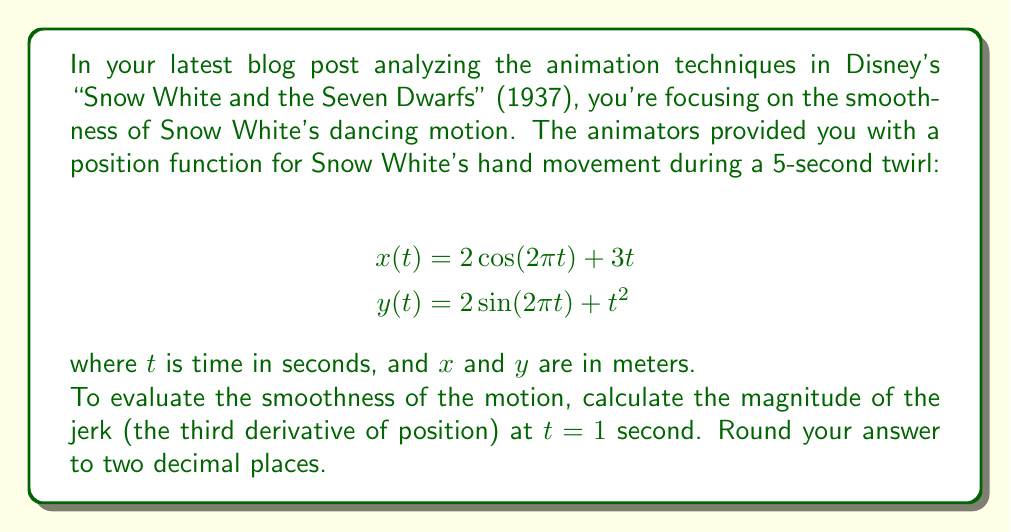What is the answer to this math problem? To evaluate the smoothness of the motion, we need to calculate the jerk, which is the third derivative of position. Let's break this down step-by-step:

1. First, we need to find the velocity components (first derivatives):
   $$\frac{dx}{dt} = -4\pi\sin(2\pi t) + 3$$
   $$\frac{dy}{dt} = 4\pi\cos(2\pi t) + 2t$$

2. Next, we calculate the acceleration components (second derivatives):
   $$\frac{d^2x}{dt^2} = -8\pi^2\cos(2\pi t)$$
   $$\frac{d^2y}{dt^2} = -8\pi^2\sin(2\pi t) + 2$$

3. Now, we find the jerk components (third derivatives):
   $$\frac{d^3x}{dt^3} = 16\pi^3\sin(2\pi t)$$
   $$\frac{d^3y}{dt^3} = -16\pi^3\cos(2\pi t)$$

4. The magnitude of the jerk is given by:
   $$\text{Jerk} = \sqrt{\left(\frac{d^3x}{dt^3}\right)^2 + \left(\frac{d^3y}{dt^3}\right)^2}$$

5. Substituting $t = 1$ into the jerk components:
   $$\frac{d^3x}{dt^3}(1) = 16\pi^3\sin(2\pi) = 0$$
   $$\frac{d^3y}{dt^3}(1) = -16\pi^3\cos(2\pi) = -16\pi^3$$

6. Calculate the magnitude of the jerk at $t = 1$:
   $$\text{Jerk} = \sqrt{0^2 + (-16\pi^3)^2} = 16\pi^3$$

7. Evaluate and round to two decimal places:
   $$16\pi^3 \approx 493.48 \text{ m/s}^3$$
Answer: 493.48 m/s³ 